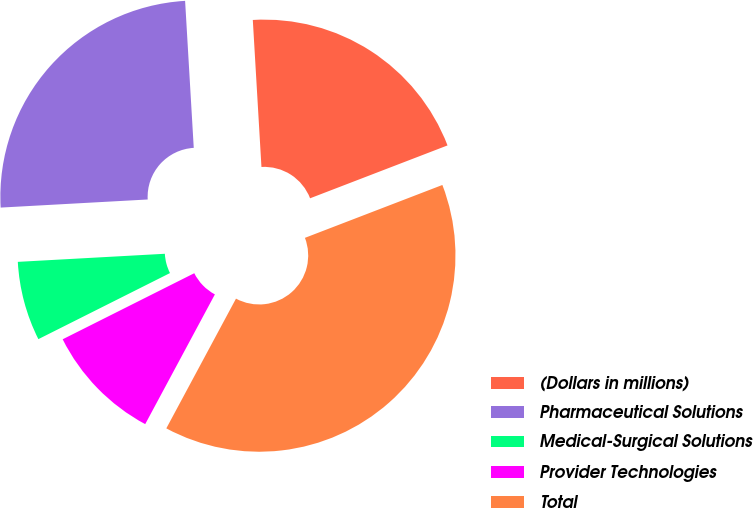<chart> <loc_0><loc_0><loc_500><loc_500><pie_chart><fcel>(Dollars in millions)<fcel>Pharmaceutical Solutions<fcel>Medical-Surgical Solutions<fcel>Provider Technologies<fcel>Total<nl><fcel>20.09%<fcel>24.94%<fcel>6.53%<fcel>9.75%<fcel>38.69%<nl></chart> 